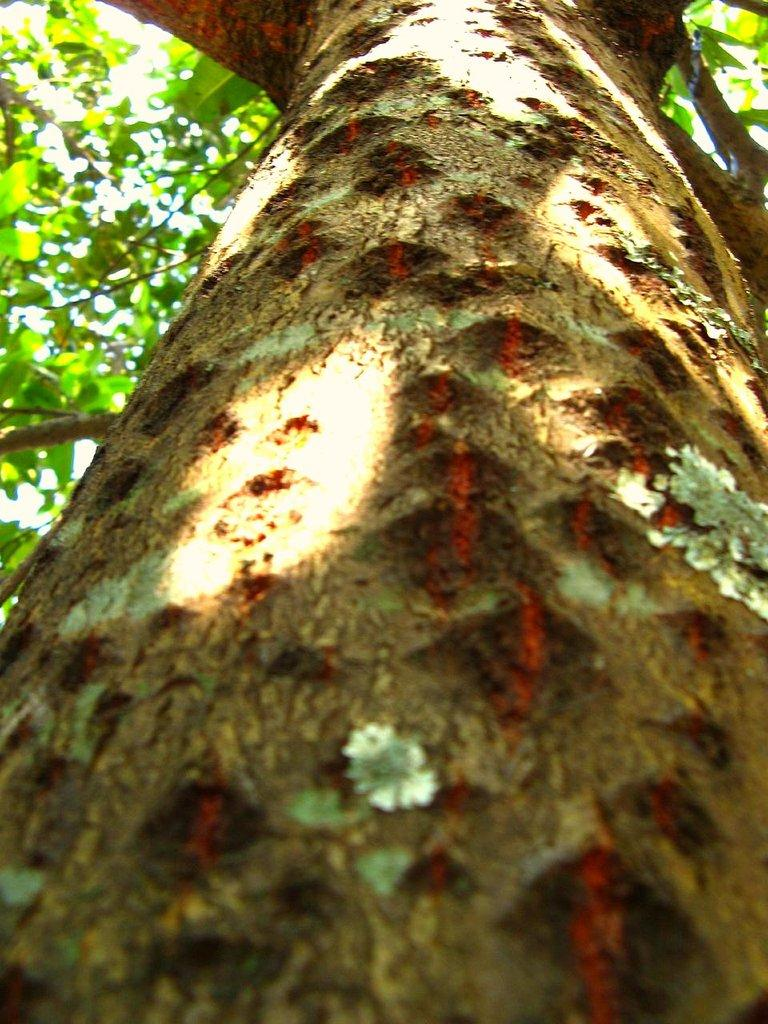What is the main subject of the picture? The main subject of the picture is a tree. Are there any other plants visible in the image? Yes, there are small, tiny plants on the trunk of the tree. What type of tomatoes can be seen growing on the tree in the image? There are no tomatoes present in the image; the tree has small, tiny plants on its trunk. What is the topic of the discussion happening under the tree in the image? There is no discussion happening under the tree in the image; it only shows the tree and the small, tiny plants on its trunk. 